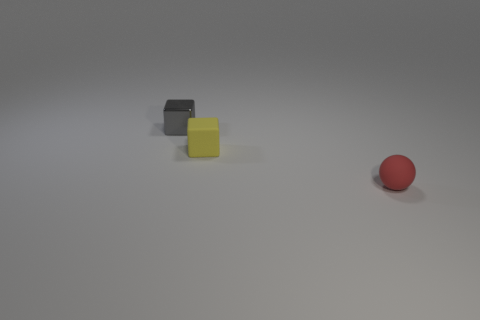How big is the yellow rubber block?
Your response must be concise. Small. How many metal things are either tiny cyan objects or tiny balls?
Offer a terse response. 0. Are there fewer tiny cubes than big purple shiny things?
Give a very brief answer. No. How many other things are there of the same material as the small gray object?
Provide a short and direct response. 0. What size is the gray thing that is the same shape as the tiny yellow rubber object?
Offer a terse response. Small. Are the tiny object that is in front of the tiny matte block and the tiny block that is in front of the tiny gray cube made of the same material?
Offer a very short reply. Yes. Is the number of matte things that are on the right side of the tiny red thing less than the number of large brown objects?
Provide a short and direct response. No. Is there any other thing that has the same shape as the small yellow matte object?
Give a very brief answer. Yes. There is another object that is the same shape as the tiny gray metallic thing; what color is it?
Ensure brevity in your answer.  Yellow. There is a block that is in front of the gray cube; does it have the same size as the gray shiny block?
Offer a terse response. Yes. 